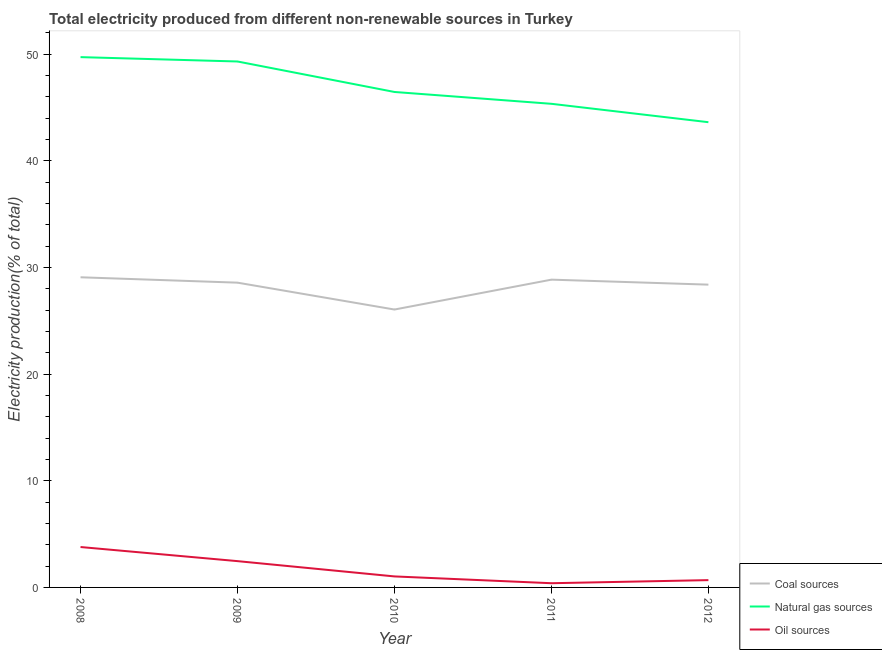How many different coloured lines are there?
Your answer should be very brief. 3. Does the line corresponding to percentage of electricity produced by coal intersect with the line corresponding to percentage of electricity produced by natural gas?
Offer a terse response. No. What is the percentage of electricity produced by natural gas in 2008?
Your response must be concise. 49.74. Across all years, what is the maximum percentage of electricity produced by coal?
Ensure brevity in your answer.  29.09. Across all years, what is the minimum percentage of electricity produced by oil sources?
Make the answer very short. 0.39. In which year was the percentage of electricity produced by natural gas maximum?
Your answer should be compact. 2008. What is the total percentage of electricity produced by coal in the graph?
Offer a very short reply. 141. What is the difference between the percentage of electricity produced by coal in 2010 and that in 2012?
Offer a very short reply. -2.34. What is the difference between the percentage of electricity produced by coal in 2012 and the percentage of electricity produced by natural gas in 2009?
Ensure brevity in your answer.  -20.93. What is the average percentage of electricity produced by coal per year?
Your answer should be very brief. 28.2. In the year 2012, what is the difference between the percentage of electricity produced by oil sources and percentage of electricity produced by coal?
Keep it short and to the point. -27.71. In how many years, is the percentage of electricity produced by coal greater than 46 %?
Offer a terse response. 0. What is the ratio of the percentage of electricity produced by coal in 2008 to that in 2010?
Provide a succinct answer. 1.12. Is the percentage of electricity produced by natural gas in 2008 less than that in 2011?
Provide a short and direct response. No. What is the difference between the highest and the second highest percentage of electricity produced by natural gas?
Your answer should be very brief. 0.41. What is the difference between the highest and the lowest percentage of electricity produced by natural gas?
Your answer should be very brief. 6.1. In how many years, is the percentage of electricity produced by coal greater than the average percentage of electricity produced by coal taken over all years?
Ensure brevity in your answer.  4. Is it the case that in every year, the sum of the percentage of electricity produced by coal and percentage of electricity produced by natural gas is greater than the percentage of electricity produced by oil sources?
Give a very brief answer. Yes. Does the percentage of electricity produced by oil sources monotonically increase over the years?
Offer a terse response. No. How many lines are there?
Give a very brief answer. 3. What is the difference between two consecutive major ticks on the Y-axis?
Offer a terse response. 10. Are the values on the major ticks of Y-axis written in scientific E-notation?
Your answer should be compact. No. Does the graph contain grids?
Ensure brevity in your answer.  No. Where does the legend appear in the graph?
Provide a short and direct response. Bottom right. How many legend labels are there?
Give a very brief answer. 3. What is the title of the graph?
Provide a succinct answer. Total electricity produced from different non-renewable sources in Turkey. What is the label or title of the Y-axis?
Ensure brevity in your answer.  Electricity production(% of total). What is the Electricity production(% of total) in Coal sources in 2008?
Keep it short and to the point. 29.09. What is the Electricity production(% of total) of Natural gas sources in 2008?
Your answer should be compact. 49.74. What is the Electricity production(% of total) in Oil sources in 2008?
Your response must be concise. 3.79. What is the Electricity production(% of total) in Coal sources in 2009?
Make the answer very short. 28.58. What is the Electricity production(% of total) in Natural gas sources in 2009?
Offer a very short reply. 49.33. What is the Electricity production(% of total) in Oil sources in 2009?
Ensure brevity in your answer.  2.47. What is the Electricity production(% of total) in Coal sources in 2010?
Give a very brief answer. 26.06. What is the Electricity production(% of total) of Natural gas sources in 2010?
Your response must be concise. 46.47. What is the Electricity production(% of total) of Oil sources in 2010?
Ensure brevity in your answer.  1.03. What is the Electricity production(% of total) in Coal sources in 2011?
Provide a succinct answer. 28.87. What is the Electricity production(% of total) in Natural gas sources in 2011?
Offer a very short reply. 45.36. What is the Electricity production(% of total) of Oil sources in 2011?
Ensure brevity in your answer.  0.39. What is the Electricity production(% of total) of Coal sources in 2012?
Ensure brevity in your answer.  28.4. What is the Electricity production(% of total) in Natural gas sources in 2012?
Provide a succinct answer. 43.63. What is the Electricity production(% of total) in Oil sources in 2012?
Give a very brief answer. 0.68. Across all years, what is the maximum Electricity production(% of total) of Coal sources?
Your response must be concise. 29.09. Across all years, what is the maximum Electricity production(% of total) of Natural gas sources?
Your response must be concise. 49.74. Across all years, what is the maximum Electricity production(% of total) of Oil sources?
Keep it short and to the point. 3.79. Across all years, what is the minimum Electricity production(% of total) of Coal sources?
Offer a terse response. 26.06. Across all years, what is the minimum Electricity production(% of total) in Natural gas sources?
Your answer should be very brief. 43.63. Across all years, what is the minimum Electricity production(% of total) of Oil sources?
Keep it short and to the point. 0.39. What is the total Electricity production(% of total) of Coal sources in the graph?
Your answer should be very brief. 141. What is the total Electricity production(% of total) of Natural gas sources in the graph?
Offer a terse response. 234.52. What is the total Electricity production(% of total) in Oil sources in the graph?
Offer a terse response. 8.37. What is the difference between the Electricity production(% of total) in Coal sources in 2008 and that in 2009?
Ensure brevity in your answer.  0.5. What is the difference between the Electricity production(% of total) of Natural gas sources in 2008 and that in 2009?
Keep it short and to the point. 0.41. What is the difference between the Electricity production(% of total) of Oil sources in 2008 and that in 2009?
Keep it short and to the point. 1.32. What is the difference between the Electricity production(% of total) in Coal sources in 2008 and that in 2010?
Make the answer very short. 3.03. What is the difference between the Electricity production(% of total) of Natural gas sources in 2008 and that in 2010?
Your response must be concise. 3.27. What is the difference between the Electricity production(% of total) in Oil sources in 2008 and that in 2010?
Provide a succinct answer. 2.76. What is the difference between the Electricity production(% of total) of Coal sources in 2008 and that in 2011?
Ensure brevity in your answer.  0.22. What is the difference between the Electricity production(% of total) in Natural gas sources in 2008 and that in 2011?
Your answer should be very brief. 4.38. What is the difference between the Electricity production(% of total) in Oil sources in 2008 and that in 2011?
Offer a very short reply. 3.4. What is the difference between the Electricity production(% of total) of Coal sources in 2008 and that in 2012?
Your answer should be very brief. 0.69. What is the difference between the Electricity production(% of total) of Natural gas sources in 2008 and that in 2012?
Offer a very short reply. 6.1. What is the difference between the Electricity production(% of total) of Oil sources in 2008 and that in 2012?
Your answer should be very brief. 3.11. What is the difference between the Electricity production(% of total) in Coal sources in 2009 and that in 2010?
Your answer should be very brief. 2.52. What is the difference between the Electricity production(% of total) in Natural gas sources in 2009 and that in 2010?
Offer a terse response. 2.86. What is the difference between the Electricity production(% of total) of Oil sources in 2009 and that in 2010?
Your answer should be compact. 1.43. What is the difference between the Electricity production(% of total) in Coal sources in 2009 and that in 2011?
Give a very brief answer. -0.28. What is the difference between the Electricity production(% of total) in Natural gas sources in 2009 and that in 2011?
Offer a very short reply. 3.97. What is the difference between the Electricity production(% of total) of Oil sources in 2009 and that in 2011?
Make the answer very short. 2.07. What is the difference between the Electricity production(% of total) of Coal sources in 2009 and that in 2012?
Offer a very short reply. 0.19. What is the difference between the Electricity production(% of total) in Natural gas sources in 2009 and that in 2012?
Your answer should be compact. 5.69. What is the difference between the Electricity production(% of total) of Oil sources in 2009 and that in 2012?
Make the answer very short. 1.78. What is the difference between the Electricity production(% of total) of Coal sources in 2010 and that in 2011?
Make the answer very short. -2.8. What is the difference between the Electricity production(% of total) of Natural gas sources in 2010 and that in 2011?
Offer a very short reply. 1.11. What is the difference between the Electricity production(% of total) of Oil sources in 2010 and that in 2011?
Ensure brevity in your answer.  0.64. What is the difference between the Electricity production(% of total) in Coal sources in 2010 and that in 2012?
Keep it short and to the point. -2.34. What is the difference between the Electricity production(% of total) in Natural gas sources in 2010 and that in 2012?
Offer a very short reply. 2.84. What is the difference between the Electricity production(% of total) of Oil sources in 2010 and that in 2012?
Keep it short and to the point. 0.35. What is the difference between the Electricity production(% of total) in Coal sources in 2011 and that in 2012?
Your response must be concise. 0.47. What is the difference between the Electricity production(% of total) of Natural gas sources in 2011 and that in 2012?
Ensure brevity in your answer.  1.73. What is the difference between the Electricity production(% of total) of Oil sources in 2011 and that in 2012?
Provide a succinct answer. -0.29. What is the difference between the Electricity production(% of total) of Coal sources in 2008 and the Electricity production(% of total) of Natural gas sources in 2009?
Your answer should be compact. -20.24. What is the difference between the Electricity production(% of total) of Coal sources in 2008 and the Electricity production(% of total) of Oil sources in 2009?
Your answer should be compact. 26.62. What is the difference between the Electricity production(% of total) of Natural gas sources in 2008 and the Electricity production(% of total) of Oil sources in 2009?
Provide a succinct answer. 47.27. What is the difference between the Electricity production(% of total) of Coal sources in 2008 and the Electricity production(% of total) of Natural gas sources in 2010?
Your answer should be compact. -17.38. What is the difference between the Electricity production(% of total) in Coal sources in 2008 and the Electricity production(% of total) in Oil sources in 2010?
Make the answer very short. 28.06. What is the difference between the Electricity production(% of total) of Natural gas sources in 2008 and the Electricity production(% of total) of Oil sources in 2010?
Make the answer very short. 48.7. What is the difference between the Electricity production(% of total) of Coal sources in 2008 and the Electricity production(% of total) of Natural gas sources in 2011?
Your response must be concise. -16.27. What is the difference between the Electricity production(% of total) in Coal sources in 2008 and the Electricity production(% of total) in Oil sources in 2011?
Your answer should be compact. 28.69. What is the difference between the Electricity production(% of total) in Natural gas sources in 2008 and the Electricity production(% of total) in Oil sources in 2011?
Keep it short and to the point. 49.34. What is the difference between the Electricity production(% of total) in Coal sources in 2008 and the Electricity production(% of total) in Natural gas sources in 2012?
Keep it short and to the point. -14.54. What is the difference between the Electricity production(% of total) of Coal sources in 2008 and the Electricity production(% of total) of Oil sources in 2012?
Your answer should be compact. 28.4. What is the difference between the Electricity production(% of total) of Natural gas sources in 2008 and the Electricity production(% of total) of Oil sources in 2012?
Offer a terse response. 49.05. What is the difference between the Electricity production(% of total) in Coal sources in 2009 and the Electricity production(% of total) in Natural gas sources in 2010?
Keep it short and to the point. -17.88. What is the difference between the Electricity production(% of total) in Coal sources in 2009 and the Electricity production(% of total) in Oil sources in 2010?
Give a very brief answer. 27.55. What is the difference between the Electricity production(% of total) in Natural gas sources in 2009 and the Electricity production(% of total) in Oil sources in 2010?
Provide a short and direct response. 48.29. What is the difference between the Electricity production(% of total) of Coal sources in 2009 and the Electricity production(% of total) of Natural gas sources in 2011?
Your answer should be compact. -16.77. What is the difference between the Electricity production(% of total) of Coal sources in 2009 and the Electricity production(% of total) of Oil sources in 2011?
Offer a very short reply. 28.19. What is the difference between the Electricity production(% of total) of Natural gas sources in 2009 and the Electricity production(% of total) of Oil sources in 2011?
Offer a terse response. 48.93. What is the difference between the Electricity production(% of total) in Coal sources in 2009 and the Electricity production(% of total) in Natural gas sources in 2012?
Offer a very short reply. -15.05. What is the difference between the Electricity production(% of total) of Coal sources in 2009 and the Electricity production(% of total) of Oil sources in 2012?
Offer a very short reply. 27.9. What is the difference between the Electricity production(% of total) in Natural gas sources in 2009 and the Electricity production(% of total) in Oil sources in 2012?
Provide a short and direct response. 48.64. What is the difference between the Electricity production(% of total) of Coal sources in 2010 and the Electricity production(% of total) of Natural gas sources in 2011?
Ensure brevity in your answer.  -19.3. What is the difference between the Electricity production(% of total) of Coal sources in 2010 and the Electricity production(% of total) of Oil sources in 2011?
Offer a terse response. 25.67. What is the difference between the Electricity production(% of total) of Natural gas sources in 2010 and the Electricity production(% of total) of Oil sources in 2011?
Keep it short and to the point. 46.07. What is the difference between the Electricity production(% of total) in Coal sources in 2010 and the Electricity production(% of total) in Natural gas sources in 2012?
Offer a terse response. -17.57. What is the difference between the Electricity production(% of total) of Coal sources in 2010 and the Electricity production(% of total) of Oil sources in 2012?
Your answer should be compact. 25.38. What is the difference between the Electricity production(% of total) of Natural gas sources in 2010 and the Electricity production(% of total) of Oil sources in 2012?
Your answer should be very brief. 45.78. What is the difference between the Electricity production(% of total) of Coal sources in 2011 and the Electricity production(% of total) of Natural gas sources in 2012?
Provide a succinct answer. -14.77. What is the difference between the Electricity production(% of total) in Coal sources in 2011 and the Electricity production(% of total) in Oil sources in 2012?
Keep it short and to the point. 28.18. What is the difference between the Electricity production(% of total) of Natural gas sources in 2011 and the Electricity production(% of total) of Oil sources in 2012?
Provide a short and direct response. 44.67. What is the average Electricity production(% of total) of Coal sources per year?
Ensure brevity in your answer.  28.2. What is the average Electricity production(% of total) in Natural gas sources per year?
Your answer should be very brief. 46.9. What is the average Electricity production(% of total) in Oil sources per year?
Give a very brief answer. 1.67. In the year 2008, what is the difference between the Electricity production(% of total) of Coal sources and Electricity production(% of total) of Natural gas sources?
Give a very brief answer. -20.65. In the year 2008, what is the difference between the Electricity production(% of total) in Coal sources and Electricity production(% of total) in Oil sources?
Keep it short and to the point. 25.3. In the year 2008, what is the difference between the Electricity production(% of total) in Natural gas sources and Electricity production(% of total) in Oil sources?
Offer a very short reply. 45.95. In the year 2009, what is the difference between the Electricity production(% of total) in Coal sources and Electricity production(% of total) in Natural gas sources?
Give a very brief answer. -20.74. In the year 2009, what is the difference between the Electricity production(% of total) of Coal sources and Electricity production(% of total) of Oil sources?
Offer a very short reply. 26.12. In the year 2009, what is the difference between the Electricity production(% of total) in Natural gas sources and Electricity production(% of total) in Oil sources?
Keep it short and to the point. 46.86. In the year 2010, what is the difference between the Electricity production(% of total) of Coal sources and Electricity production(% of total) of Natural gas sources?
Your answer should be very brief. -20.41. In the year 2010, what is the difference between the Electricity production(% of total) of Coal sources and Electricity production(% of total) of Oil sources?
Your response must be concise. 25.03. In the year 2010, what is the difference between the Electricity production(% of total) of Natural gas sources and Electricity production(% of total) of Oil sources?
Give a very brief answer. 45.44. In the year 2011, what is the difference between the Electricity production(% of total) of Coal sources and Electricity production(% of total) of Natural gas sources?
Provide a succinct answer. -16.49. In the year 2011, what is the difference between the Electricity production(% of total) in Coal sources and Electricity production(% of total) in Oil sources?
Ensure brevity in your answer.  28.47. In the year 2011, what is the difference between the Electricity production(% of total) in Natural gas sources and Electricity production(% of total) in Oil sources?
Ensure brevity in your answer.  44.96. In the year 2012, what is the difference between the Electricity production(% of total) of Coal sources and Electricity production(% of total) of Natural gas sources?
Provide a succinct answer. -15.23. In the year 2012, what is the difference between the Electricity production(% of total) in Coal sources and Electricity production(% of total) in Oil sources?
Keep it short and to the point. 27.71. In the year 2012, what is the difference between the Electricity production(% of total) of Natural gas sources and Electricity production(% of total) of Oil sources?
Your response must be concise. 42.95. What is the ratio of the Electricity production(% of total) in Coal sources in 2008 to that in 2009?
Provide a short and direct response. 1.02. What is the ratio of the Electricity production(% of total) in Natural gas sources in 2008 to that in 2009?
Provide a short and direct response. 1.01. What is the ratio of the Electricity production(% of total) of Oil sources in 2008 to that in 2009?
Your answer should be compact. 1.54. What is the ratio of the Electricity production(% of total) in Coal sources in 2008 to that in 2010?
Your answer should be compact. 1.12. What is the ratio of the Electricity production(% of total) in Natural gas sources in 2008 to that in 2010?
Your response must be concise. 1.07. What is the ratio of the Electricity production(% of total) of Oil sources in 2008 to that in 2010?
Make the answer very short. 3.67. What is the ratio of the Electricity production(% of total) in Coal sources in 2008 to that in 2011?
Ensure brevity in your answer.  1.01. What is the ratio of the Electricity production(% of total) in Natural gas sources in 2008 to that in 2011?
Make the answer very short. 1.1. What is the ratio of the Electricity production(% of total) in Oil sources in 2008 to that in 2011?
Make the answer very short. 9.62. What is the ratio of the Electricity production(% of total) of Coal sources in 2008 to that in 2012?
Your response must be concise. 1.02. What is the ratio of the Electricity production(% of total) in Natural gas sources in 2008 to that in 2012?
Give a very brief answer. 1.14. What is the ratio of the Electricity production(% of total) of Oil sources in 2008 to that in 2012?
Your answer should be compact. 5.54. What is the ratio of the Electricity production(% of total) of Coal sources in 2009 to that in 2010?
Provide a short and direct response. 1.1. What is the ratio of the Electricity production(% of total) in Natural gas sources in 2009 to that in 2010?
Provide a short and direct response. 1.06. What is the ratio of the Electricity production(% of total) in Oil sources in 2009 to that in 2010?
Your answer should be compact. 2.39. What is the ratio of the Electricity production(% of total) of Coal sources in 2009 to that in 2011?
Ensure brevity in your answer.  0.99. What is the ratio of the Electricity production(% of total) of Natural gas sources in 2009 to that in 2011?
Provide a succinct answer. 1.09. What is the ratio of the Electricity production(% of total) in Oil sources in 2009 to that in 2011?
Keep it short and to the point. 6.26. What is the ratio of the Electricity production(% of total) in Natural gas sources in 2009 to that in 2012?
Provide a succinct answer. 1.13. What is the ratio of the Electricity production(% of total) of Oil sources in 2009 to that in 2012?
Ensure brevity in your answer.  3.6. What is the ratio of the Electricity production(% of total) of Coal sources in 2010 to that in 2011?
Keep it short and to the point. 0.9. What is the ratio of the Electricity production(% of total) in Natural gas sources in 2010 to that in 2011?
Offer a very short reply. 1.02. What is the ratio of the Electricity production(% of total) in Oil sources in 2010 to that in 2011?
Offer a terse response. 2.62. What is the ratio of the Electricity production(% of total) of Coal sources in 2010 to that in 2012?
Offer a very short reply. 0.92. What is the ratio of the Electricity production(% of total) of Natural gas sources in 2010 to that in 2012?
Your answer should be very brief. 1.06. What is the ratio of the Electricity production(% of total) in Oil sources in 2010 to that in 2012?
Offer a very short reply. 1.51. What is the ratio of the Electricity production(% of total) in Coal sources in 2011 to that in 2012?
Keep it short and to the point. 1.02. What is the ratio of the Electricity production(% of total) of Natural gas sources in 2011 to that in 2012?
Your answer should be very brief. 1.04. What is the ratio of the Electricity production(% of total) of Oil sources in 2011 to that in 2012?
Your answer should be very brief. 0.58. What is the difference between the highest and the second highest Electricity production(% of total) of Coal sources?
Offer a terse response. 0.22. What is the difference between the highest and the second highest Electricity production(% of total) in Natural gas sources?
Your answer should be compact. 0.41. What is the difference between the highest and the second highest Electricity production(% of total) of Oil sources?
Give a very brief answer. 1.32. What is the difference between the highest and the lowest Electricity production(% of total) in Coal sources?
Your answer should be compact. 3.03. What is the difference between the highest and the lowest Electricity production(% of total) in Natural gas sources?
Your answer should be compact. 6.1. What is the difference between the highest and the lowest Electricity production(% of total) of Oil sources?
Make the answer very short. 3.4. 